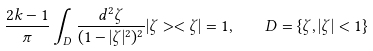<formula> <loc_0><loc_0><loc_500><loc_500>\frac { 2 k - 1 } { \pi } \int _ { D } \frac { d ^ { 2 } \zeta } { ( 1 - | \zeta | ^ { 2 } ) ^ { 2 } } | \zeta > < \zeta | = 1 , \quad D = \{ \zeta , | \zeta | < 1 \}</formula> 